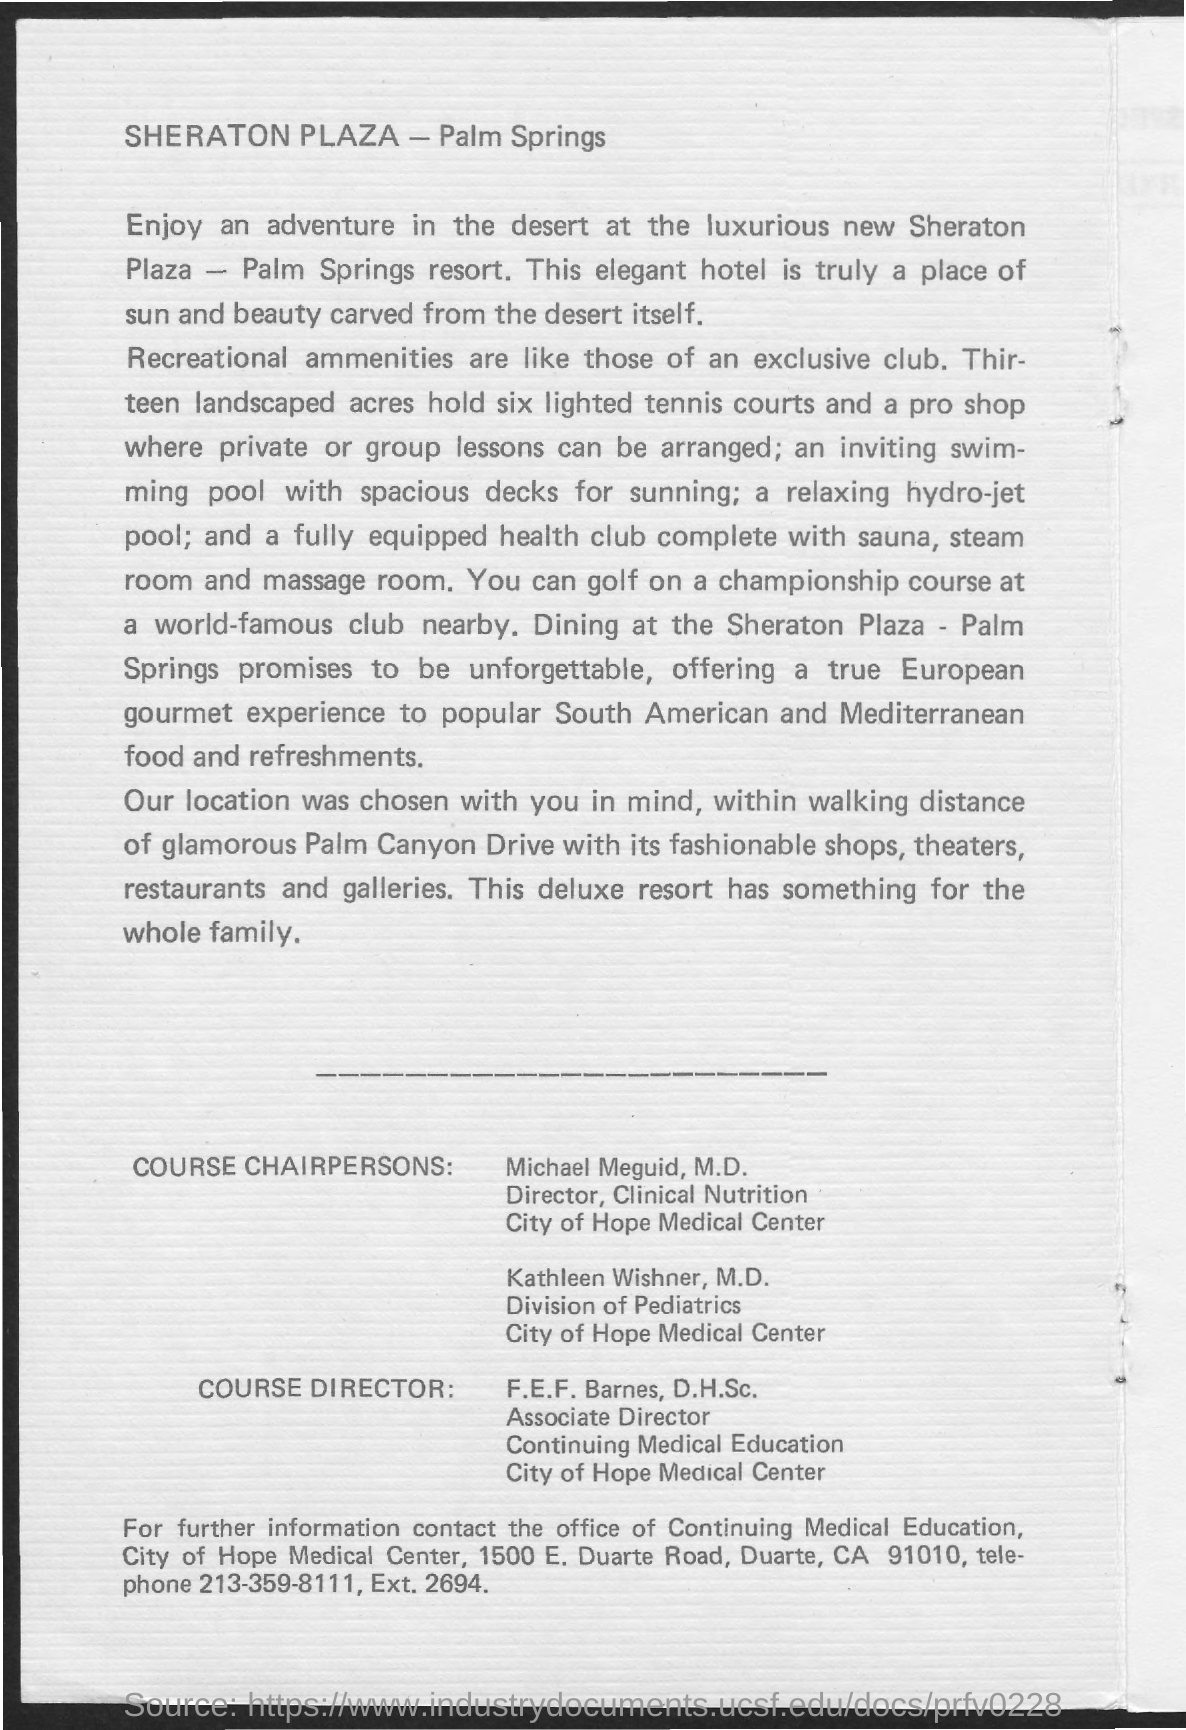Identify some key points in this picture. The associate director of Continuing Medical Education is F.E.F. Barnes and D.H.S.C. The telephone is a means of obtaining further information, and the number to reach it is 213-359-8111. The name of the Director of Clinical Nutrition is Michael Meguid, M.D. 